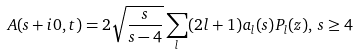Convert formula to latex. <formula><loc_0><loc_0><loc_500><loc_500>A ( s + i 0 , t ) = 2 \sqrt { \frac { s } { s - 4 } } \sum _ { l } ( 2 l + 1 ) a _ { l } ( s ) P _ { l } ( z ) , \, s \geq 4</formula> 